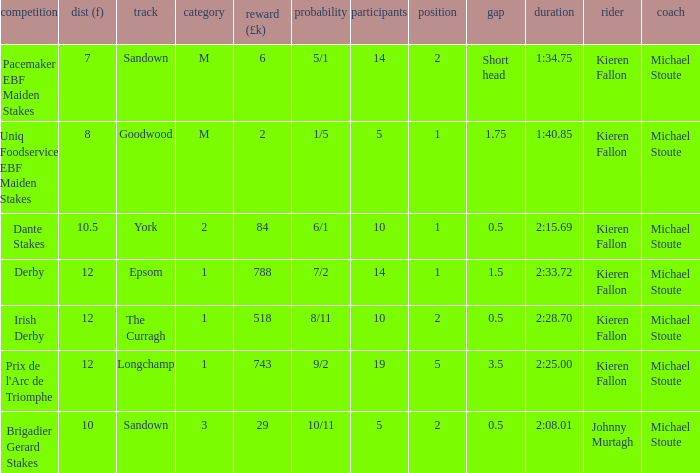Name the least runners with dist of 10.5 10.0. 